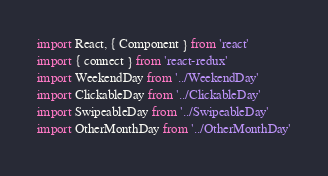<code> <loc_0><loc_0><loc_500><loc_500><_JavaScript_>import React, { Component } from 'react'
import { connect } from 'react-redux'
import WeekendDay from '../WeekendDay'
import ClickableDay from '../ClickableDay'
import SwipeableDay from '../SwipeableDay'
import OtherMonthDay from '../OtherMonthDay'</code> 